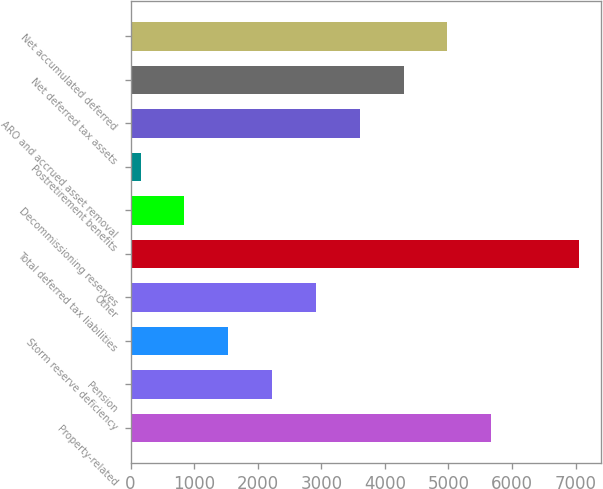<chart> <loc_0><loc_0><loc_500><loc_500><bar_chart><fcel>Property-related<fcel>Pension<fcel>Storm reserve deficiency<fcel>Other<fcel>Total deferred tax liabilities<fcel>Decommissioning reserves<fcel>Postretirement benefits<fcel>ARO and accrued asset removal<fcel>Net deferred tax assets<fcel>Net accumulated deferred<nl><fcel>5674.6<fcel>2226.1<fcel>1536.4<fcel>2915.8<fcel>7054<fcel>846.7<fcel>157<fcel>3605.5<fcel>4295.2<fcel>4984.9<nl></chart> 